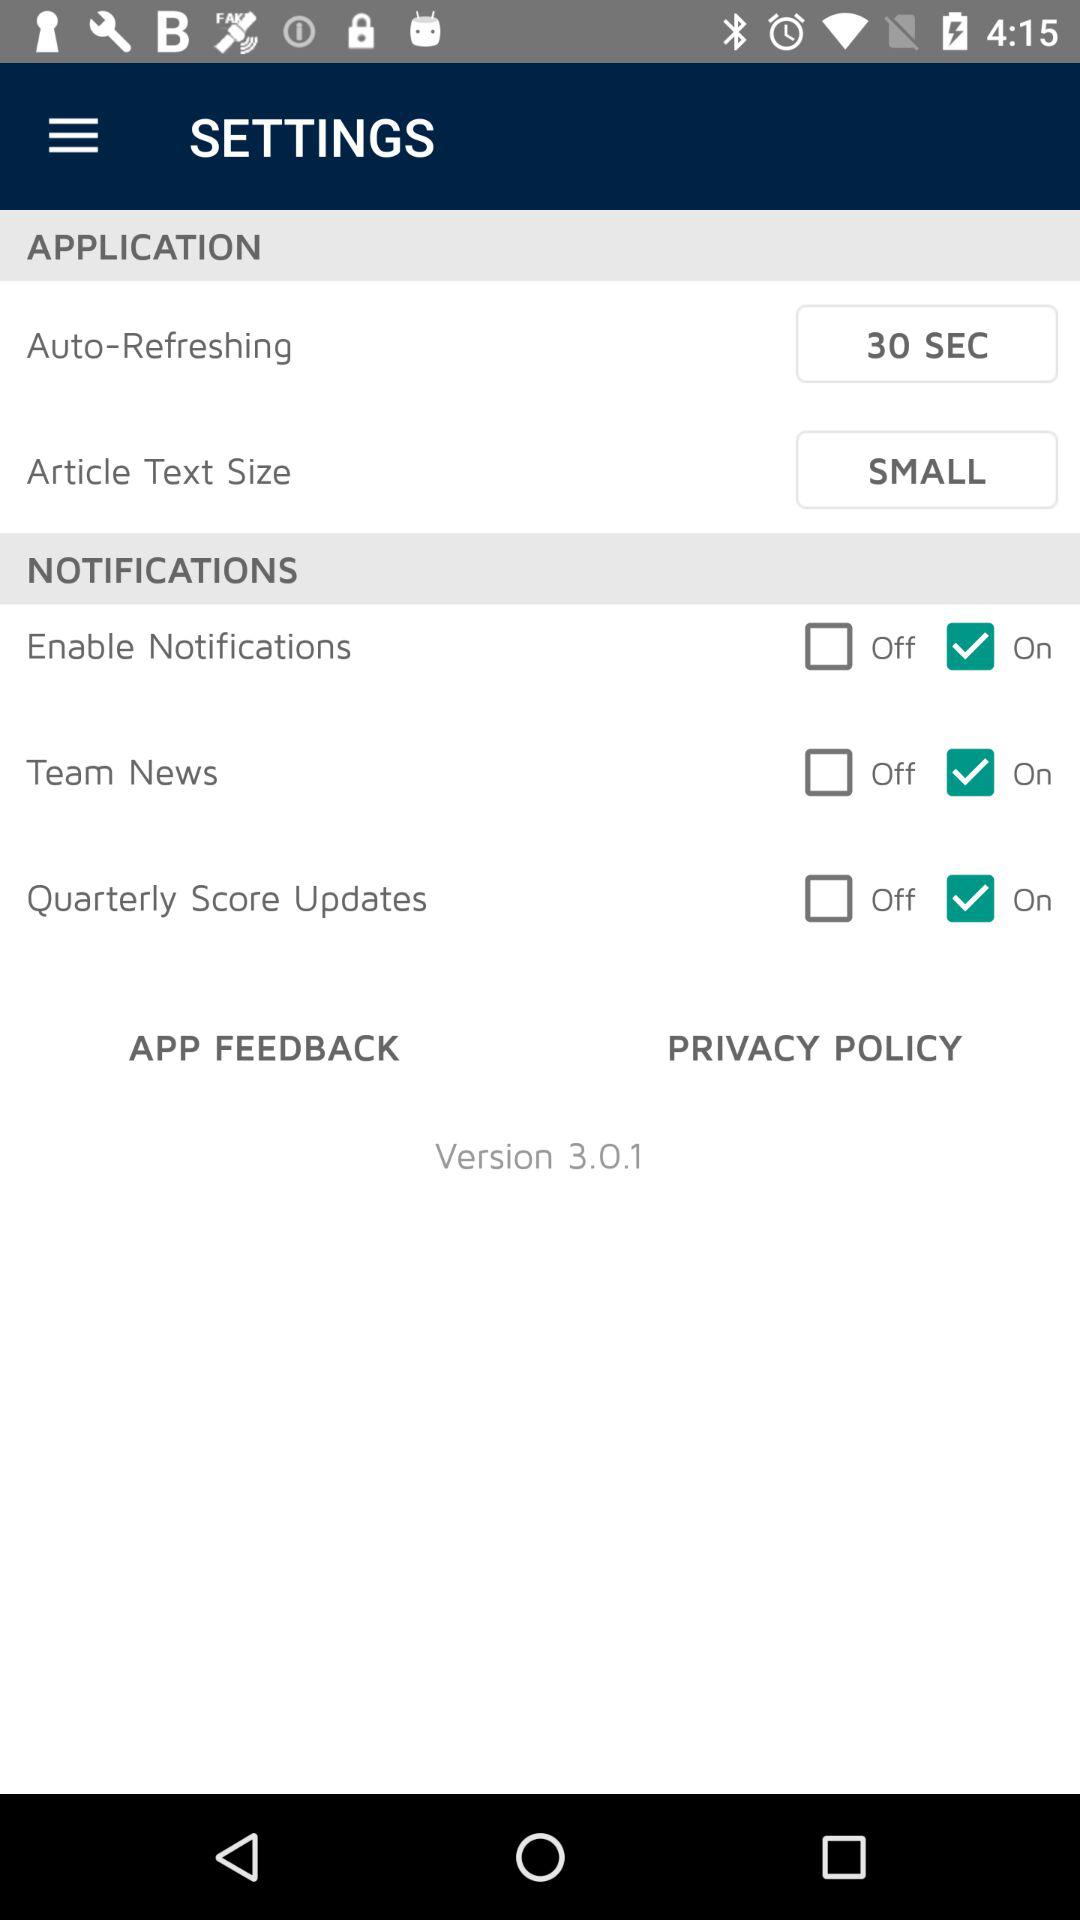What is the setting for the article text size in "APPLICATION"? The setting is "SMALL". 